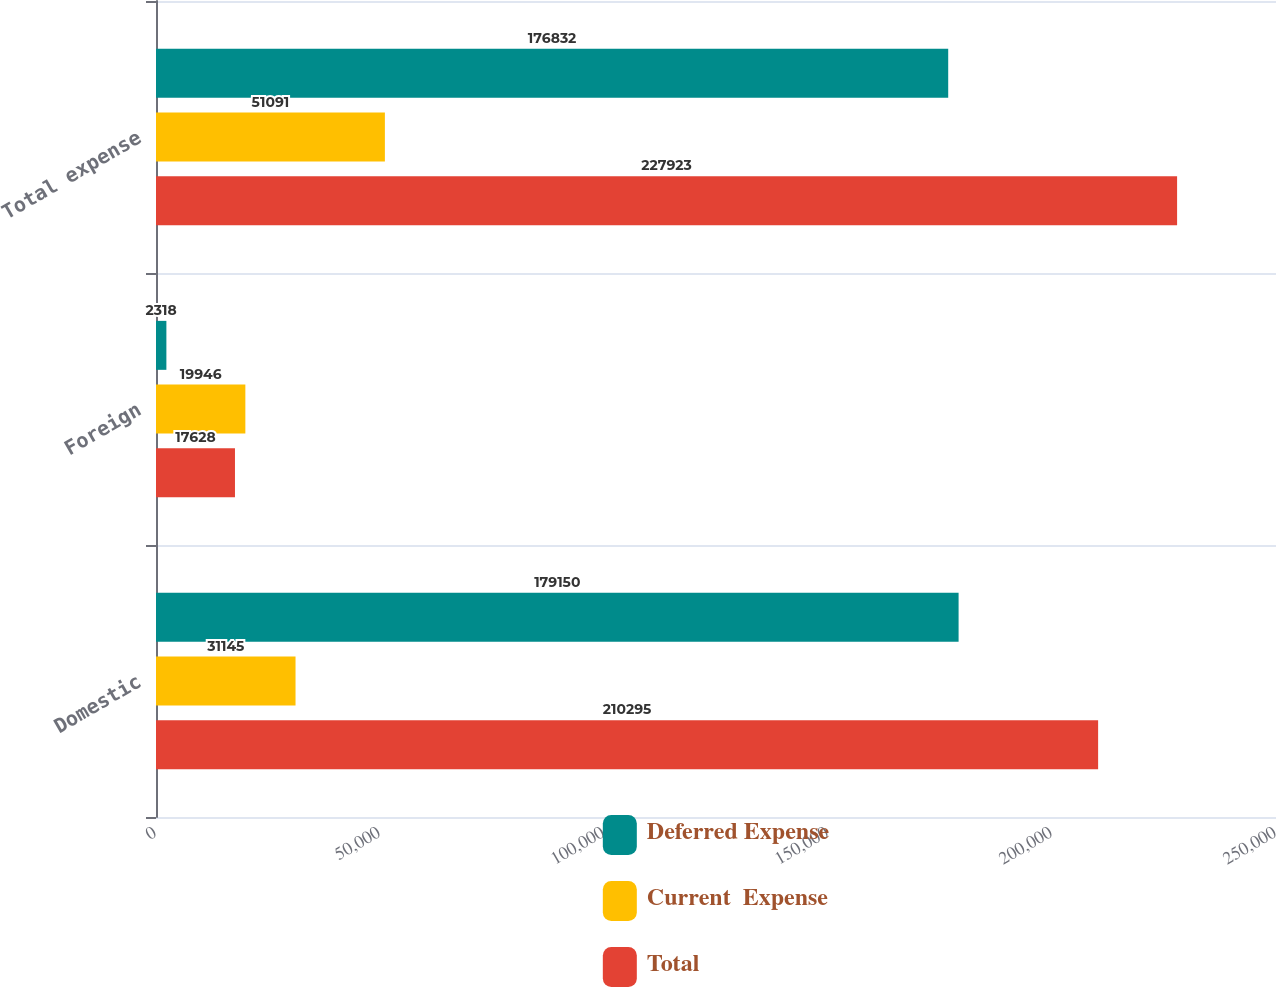Convert chart. <chart><loc_0><loc_0><loc_500><loc_500><stacked_bar_chart><ecel><fcel>Domestic<fcel>Foreign<fcel>Total expense<nl><fcel>Deferred Expense<fcel>179150<fcel>2318<fcel>176832<nl><fcel>Current  Expense<fcel>31145<fcel>19946<fcel>51091<nl><fcel>Total<fcel>210295<fcel>17628<fcel>227923<nl></chart> 